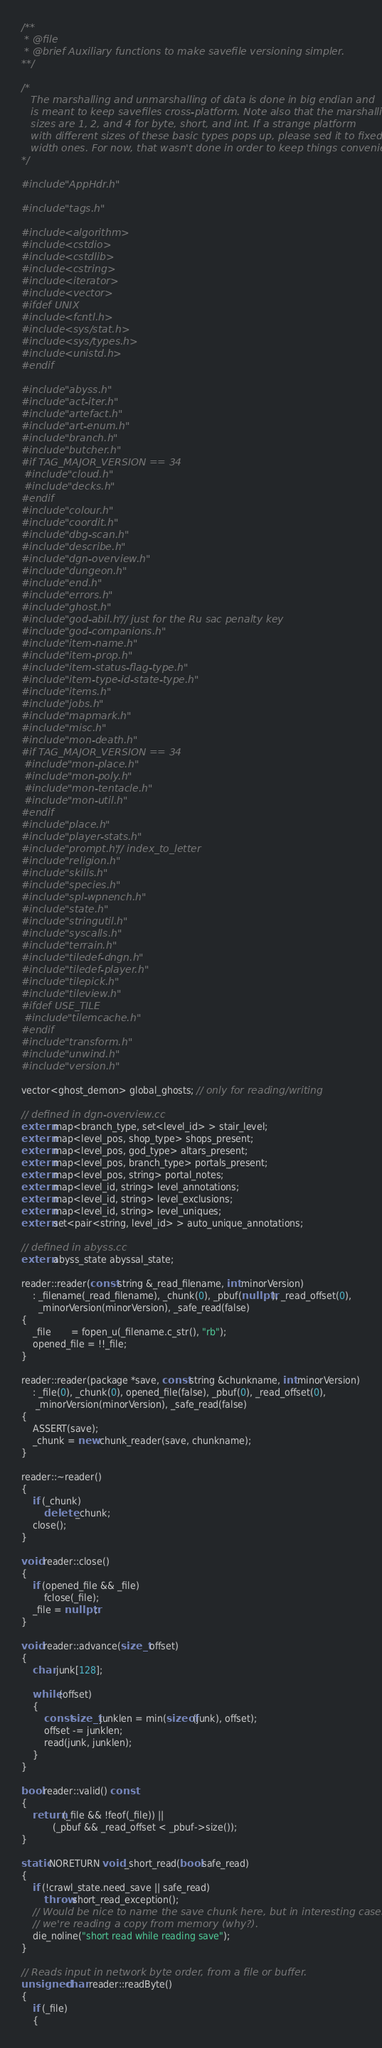<code> <loc_0><loc_0><loc_500><loc_500><_C++_>/**
 * @file
 * @brief Auxiliary functions to make savefile versioning simpler.
**/

/*
   The marshalling and unmarshalling of data is done in big endian and
   is meant to keep savefiles cross-platform. Note also that the marshalling
   sizes are 1, 2, and 4 for byte, short, and int. If a strange platform
   with different sizes of these basic types pops up, please sed it to fixed-
   width ones. For now, that wasn't done in order to keep things convenient.
*/

#include "AppHdr.h"

#include "tags.h"

#include <algorithm>
#include <cstdio>
#include <cstdlib>
#include <cstring>
#include <iterator>
#include <vector>
#ifdef UNIX
#include <fcntl.h>
#include <sys/stat.h>
#include <sys/types.h>
#include <unistd.h>
#endif

#include "abyss.h"
#include "act-iter.h"
#include "artefact.h"
#include "art-enum.h"
#include "branch.h"
#include "butcher.h"
#if TAG_MAJOR_VERSION == 34
 #include "cloud.h"
 #include "decks.h"
#endif
#include "colour.h"
#include "coordit.h"
#include "dbg-scan.h"
#include "describe.h"
#include "dgn-overview.h"
#include "dungeon.h"
#include "end.h"
#include "errors.h"
#include "ghost.h"
#include "god-abil.h" // just for the Ru sac penalty key
#include "god-companions.h"
#include "item-name.h"
#include "item-prop.h"
#include "item-status-flag-type.h"
#include "item-type-id-state-type.h"
#include "items.h"
#include "jobs.h"
#include "mapmark.h"
#include "misc.h"
#include "mon-death.h"
#if TAG_MAJOR_VERSION == 34
 #include "mon-place.h"
 #include "mon-poly.h"
 #include "mon-tentacle.h"
 #include "mon-util.h"
#endif
#include "place.h"
#include "player-stats.h"
#include "prompt.h" // index_to_letter
#include "religion.h"
#include "skills.h"
#include "species.h"
#include "spl-wpnench.h"
#include "state.h"
#include "stringutil.h"
#include "syscalls.h"
#include "terrain.h"
#include "tiledef-dngn.h"
#include "tiledef-player.h"
#include "tilepick.h"
#include "tileview.h"
#ifdef USE_TILE
 #include "tilemcache.h"
#endif
#include "transform.h"
#include "unwind.h"
#include "version.h"

vector<ghost_demon> global_ghosts; // only for reading/writing

// defined in dgn-overview.cc
extern map<branch_type, set<level_id> > stair_level;
extern map<level_pos, shop_type> shops_present;
extern map<level_pos, god_type> altars_present;
extern map<level_pos, branch_type> portals_present;
extern map<level_pos, string> portal_notes;
extern map<level_id, string> level_annotations;
extern map<level_id, string> level_exclusions;
extern map<level_id, string> level_uniques;
extern set<pair<string, level_id> > auto_unique_annotations;

// defined in abyss.cc
extern abyss_state abyssal_state;

reader::reader(const string &_read_filename, int minorVersion)
    : _filename(_read_filename), _chunk(0), _pbuf(nullptr), _read_offset(0),
      _minorVersion(minorVersion), _safe_read(false)
{
    _file       = fopen_u(_filename.c_str(), "rb");
    opened_file = !!_file;
}

reader::reader(package *save, const string &chunkname, int minorVersion)
    : _file(0), _chunk(0), opened_file(false), _pbuf(0), _read_offset(0),
     _minorVersion(minorVersion), _safe_read(false)
{
    ASSERT(save);
    _chunk = new chunk_reader(save, chunkname);
}

reader::~reader()
{
    if (_chunk)
        delete _chunk;
    close();
}

void reader::close()
{
    if (opened_file && _file)
        fclose(_file);
    _file = nullptr;
}

void reader::advance(size_t offset)
{
    char junk[128];

    while (offset)
    {
        const size_t junklen = min(sizeof(junk), offset);
        offset -= junklen;
        read(junk, junklen);
    }
}

bool reader::valid() const
{
    return (_file && !feof(_file)) ||
           (_pbuf && _read_offset < _pbuf->size());
}

static NORETURN void _short_read(bool safe_read)
{
    if (!crawl_state.need_save || safe_read)
        throw short_read_exception();
    // Would be nice to name the save chunk here, but in interesting cases
    // we're reading a copy from memory (why?).
    die_noline("short read while reading save");
}

// Reads input in network byte order, from a file or buffer.
unsigned char reader::readByte()
{
    if (_file)
    {</code> 